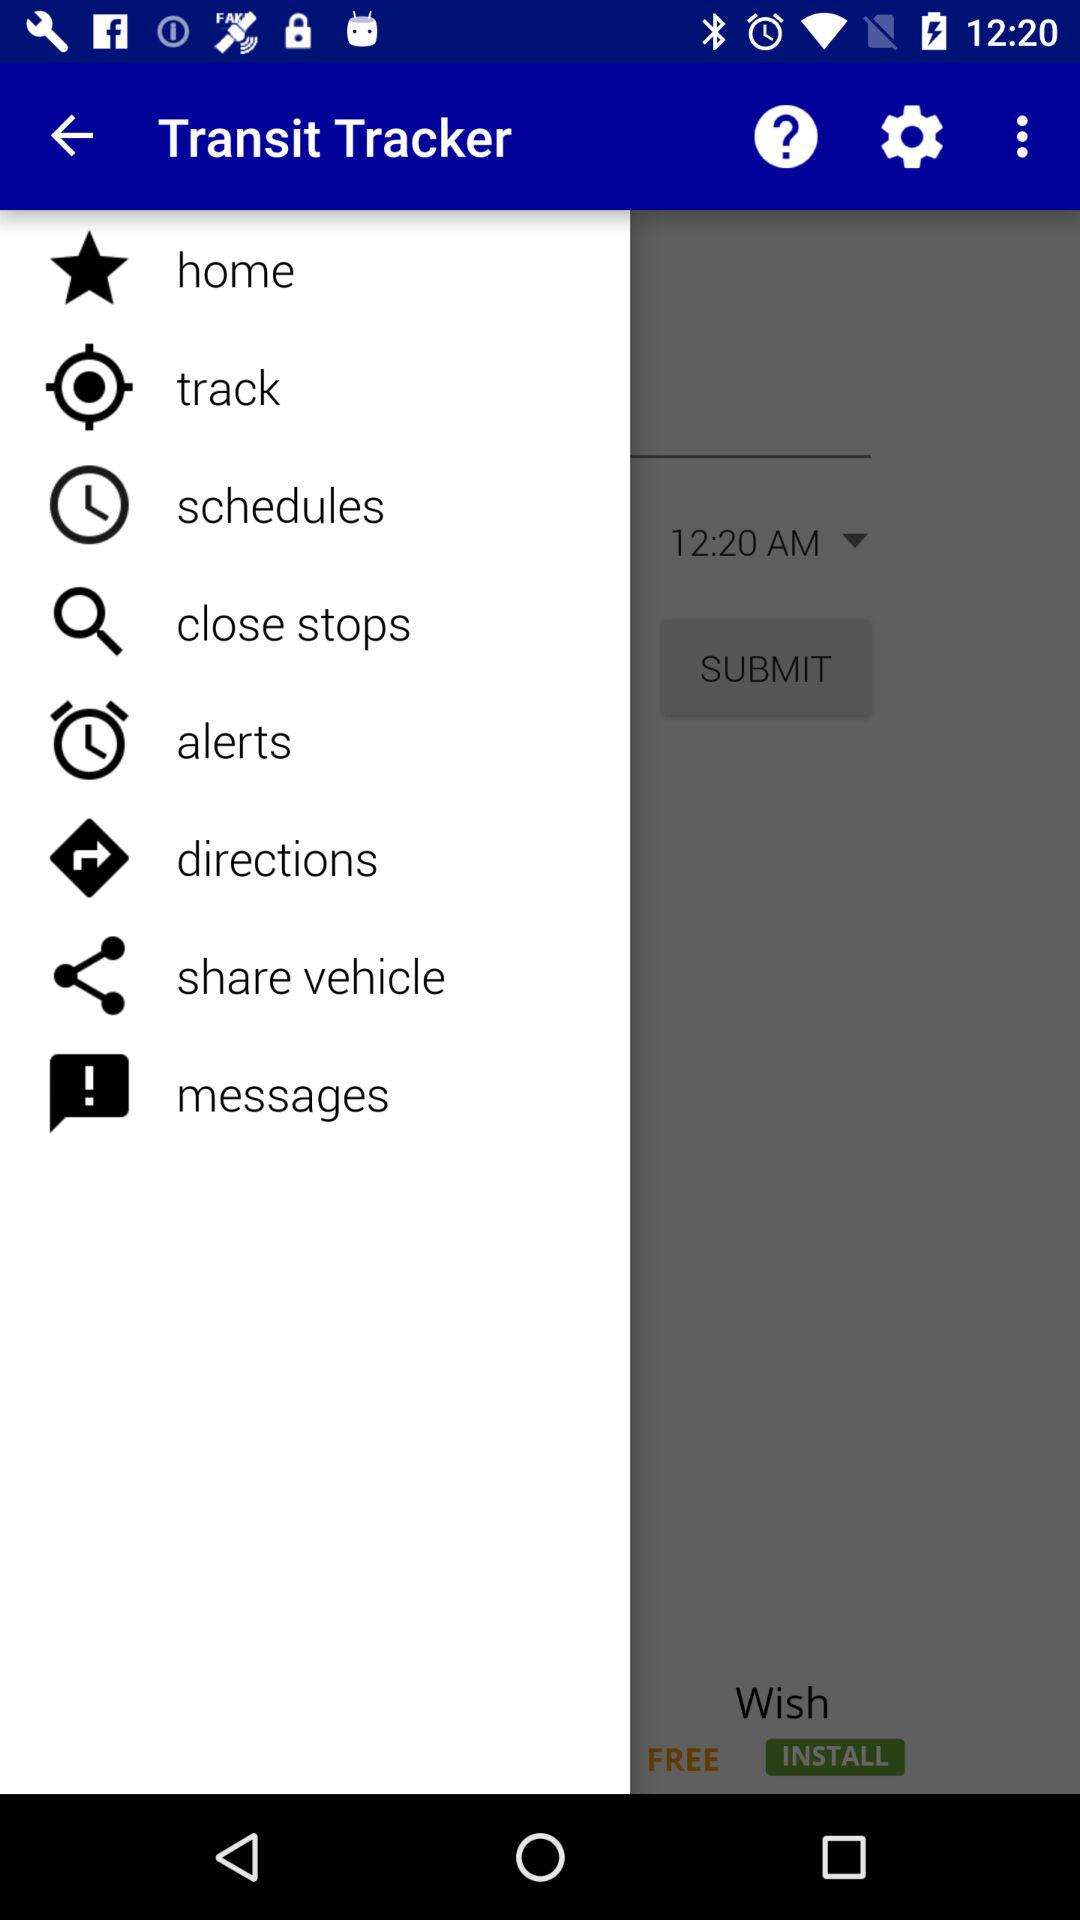What is the application name? The application name is "Transit Tracker". 